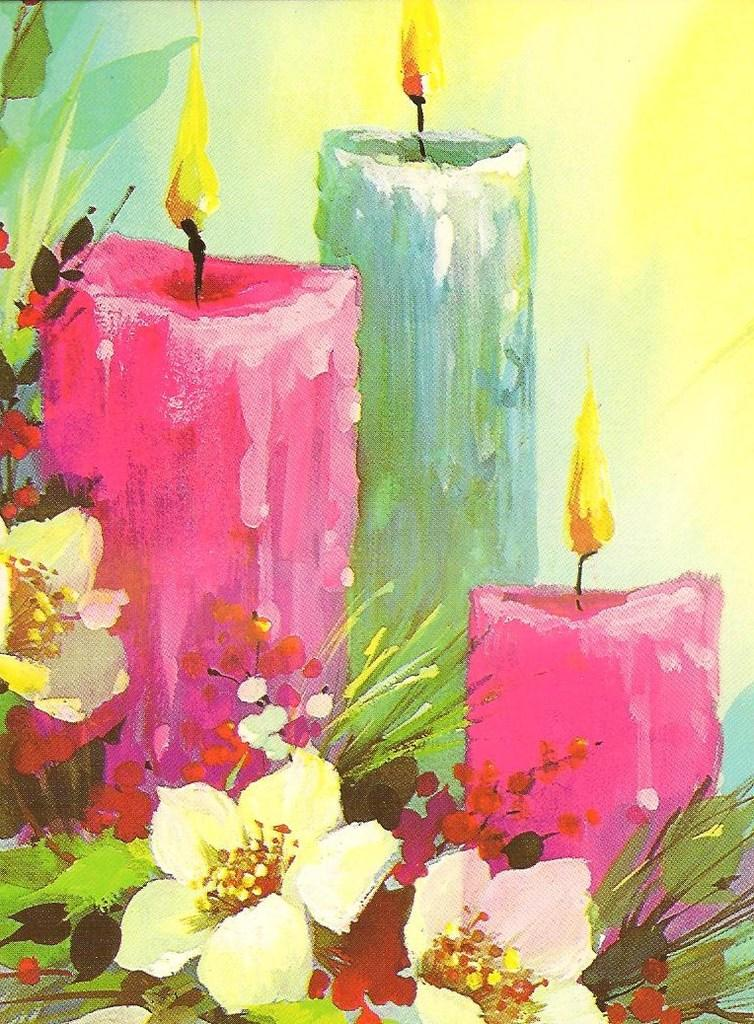What is the main subject of the image? The main subject of the image is a painting. What does the painting depict? The painting depicts candles and flowers. How many clams are visible in the painting? There are no clams visible in the painting; it depicts candles and flowers. What type of oven is shown in the painting? There is no oven present in the painting; it depicts candles and flowers. 